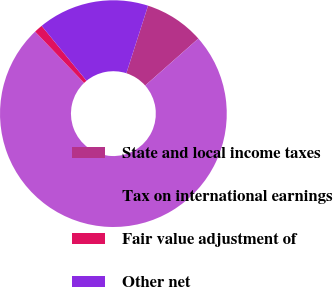<chart> <loc_0><loc_0><loc_500><loc_500><pie_chart><fcel>State and local income taxes<fcel>Tax on international earnings<fcel>Fair value adjustment of<fcel>Other net<nl><fcel>8.54%<fcel>74.39%<fcel>1.22%<fcel>15.85%<nl></chart> 